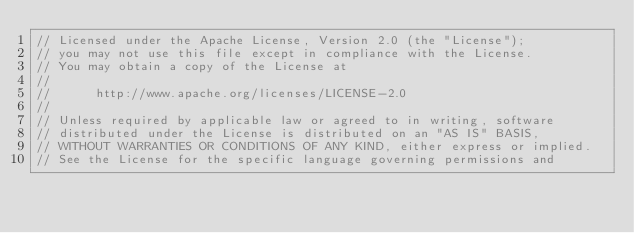<code> <loc_0><loc_0><loc_500><loc_500><_Java_>// Licensed under the Apache License, Version 2.0 (the "License");
// you may not use this file except in compliance with the License.
// You may obtain a copy of the License at
//
//      http://www.apache.org/licenses/LICENSE-2.0
//
// Unless required by applicable law or agreed to in writing, software
// distributed under the License is distributed on an "AS IS" BASIS,
// WITHOUT WARRANTIES OR CONDITIONS OF ANY KIND, either express or implied.
// See the License for the specific language governing permissions and</code> 